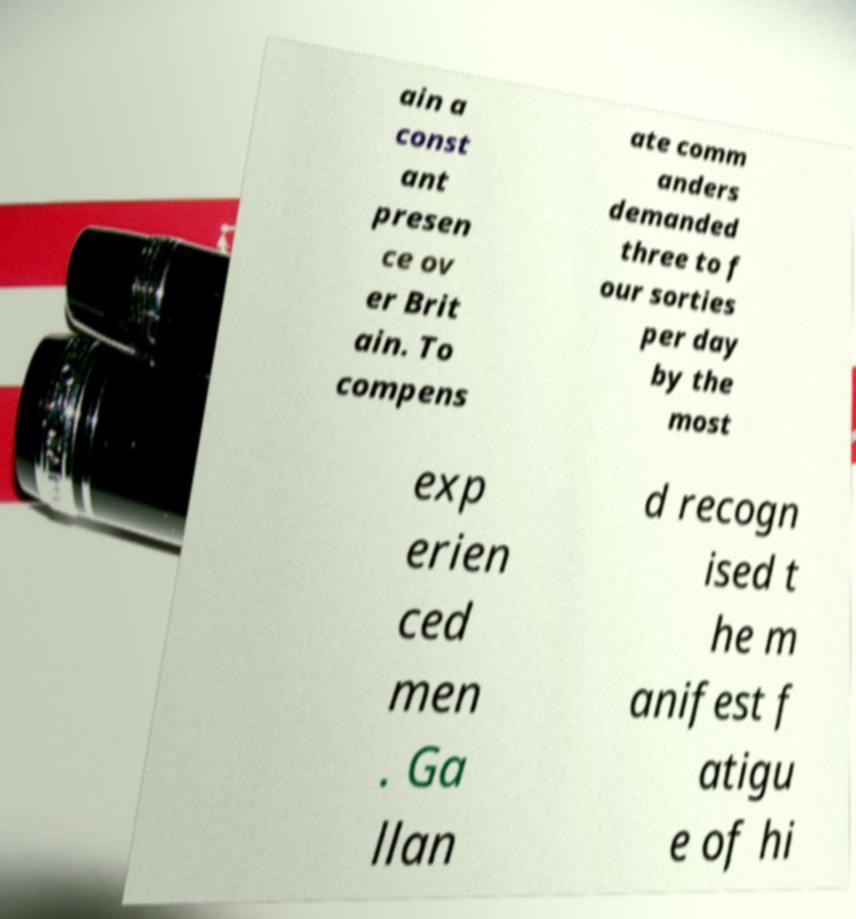Please identify and transcribe the text found in this image. ain a const ant presen ce ov er Brit ain. To compens ate comm anders demanded three to f our sorties per day by the most exp erien ced men . Ga llan d recogn ised t he m anifest f atigu e of hi 